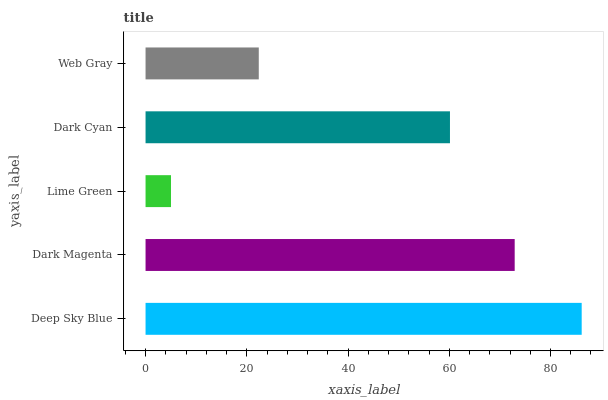Is Lime Green the minimum?
Answer yes or no. Yes. Is Deep Sky Blue the maximum?
Answer yes or no. Yes. Is Dark Magenta the minimum?
Answer yes or no. No. Is Dark Magenta the maximum?
Answer yes or no. No. Is Deep Sky Blue greater than Dark Magenta?
Answer yes or no. Yes. Is Dark Magenta less than Deep Sky Blue?
Answer yes or no. Yes. Is Dark Magenta greater than Deep Sky Blue?
Answer yes or no. No. Is Deep Sky Blue less than Dark Magenta?
Answer yes or no. No. Is Dark Cyan the high median?
Answer yes or no. Yes. Is Dark Cyan the low median?
Answer yes or no. Yes. Is Deep Sky Blue the high median?
Answer yes or no. No. Is Lime Green the low median?
Answer yes or no. No. 